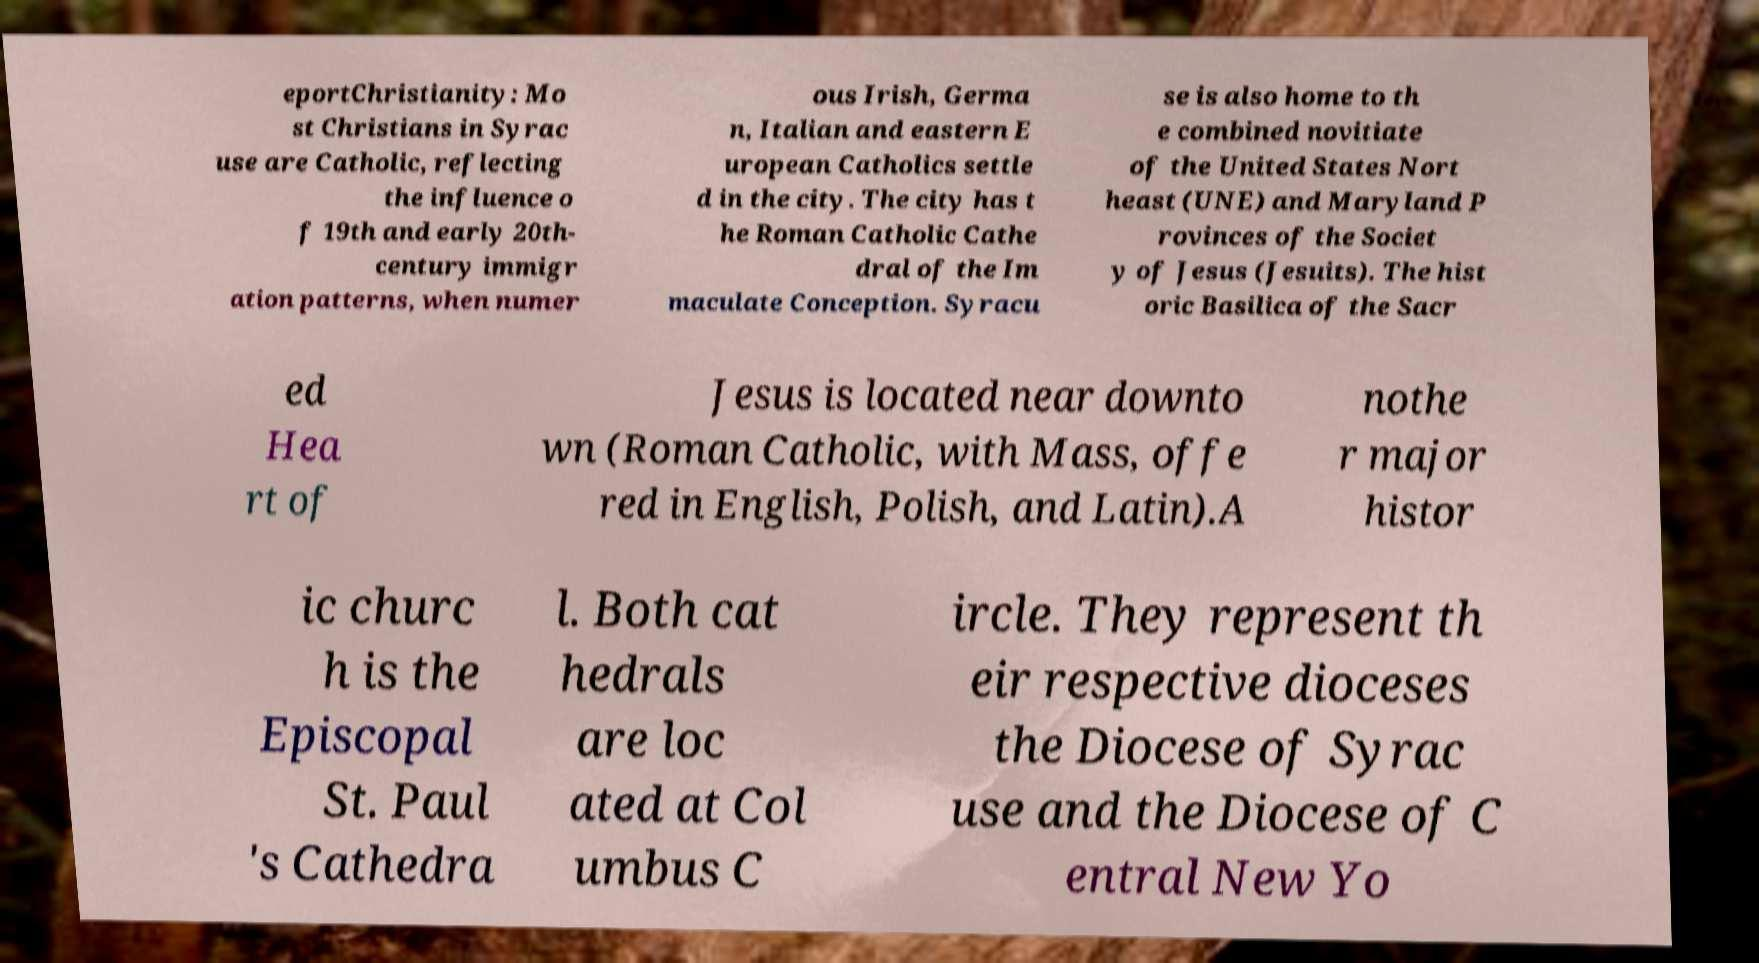Can you read and provide the text displayed in the image?This photo seems to have some interesting text. Can you extract and type it out for me? eportChristianity: Mo st Christians in Syrac use are Catholic, reflecting the influence o f 19th and early 20th- century immigr ation patterns, when numer ous Irish, Germa n, Italian and eastern E uropean Catholics settle d in the city. The city has t he Roman Catholic Cathe dral of the Im maculate Conception. Syracu se is also home to th e combined novitiate of the United States Nort heast (UNE) and Maryland P rovinces of the Societ y of Jesus (Jesuits). The hist oric Basilica of the Sacr ed Hea rt of Jesus is located near downto wn (Roman Catholic, with Mass, offe red in English, Polish, and Latin).A nothe r major histor ic churc h is the Episcopal St. Paul 's Cathedra l. Both cat hedrals are loc ated at Col umbus C ircle. They represent th eir respective dioceses the Diocese of Syrac use and the Diocese of C entral New Yo 